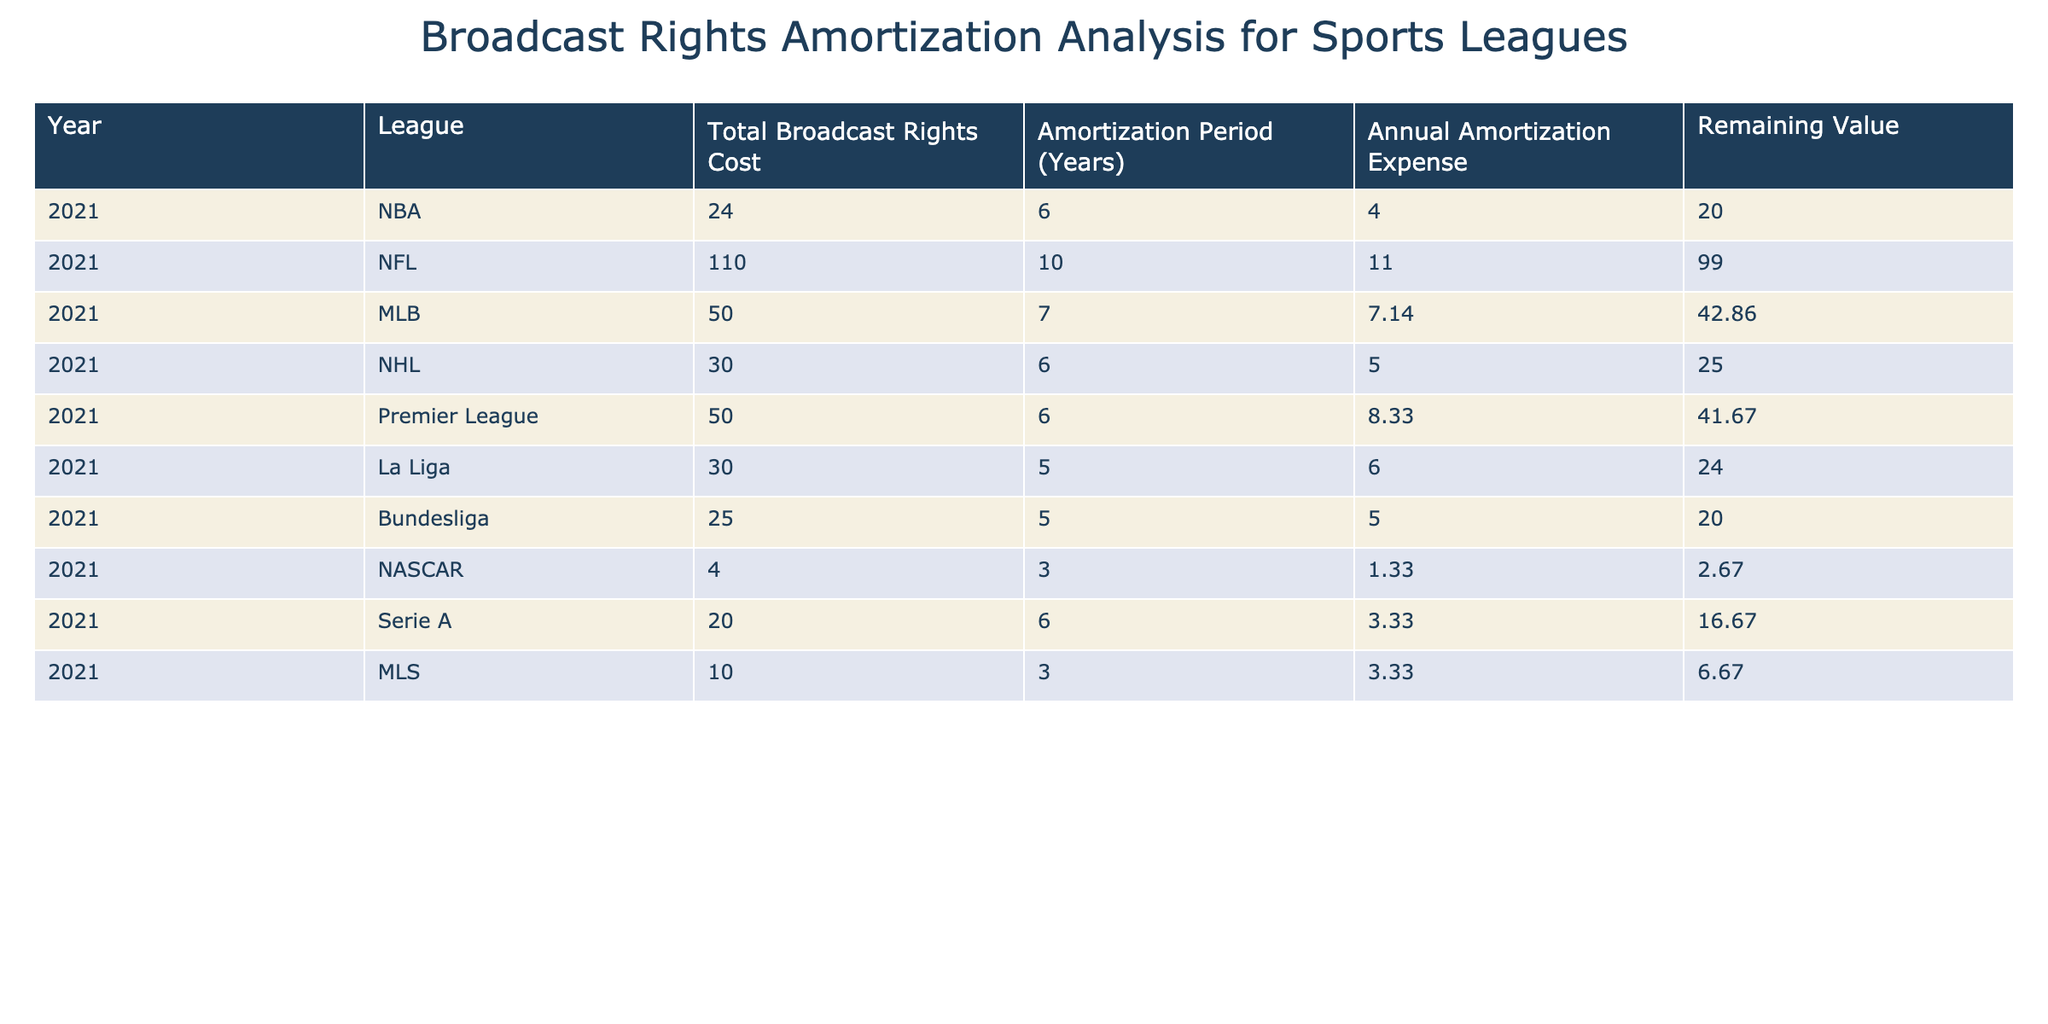What is the total broadcast rights cost for the NFL? Referring to the table, the 'Total Broadcast Rights Cost' for the NFL in the year 2021 is found in the row for the NFL, which states 110.
Answer: 110 Which league has the highest annual amortization expense? By comparing the 'Annual Amortization Expense' column across all leagues, we see that the NFL's value is 11, which is higher than all others.
Answer: NFL What is the remaining value of MLB broadcast rights after one year of amortization? From the table, the 'Remaining Value' for MLB, after one year of amortization, is 42.86 as directly stated in the corresponding row.
Answer: 42.86 Calculate the average annual amortization expense for all leagues combined. First, sum the 'Annual Amortization Expense' values: 4 + 11 + 7.14 + 5 + 8.33 + 6 + 5 + 1.33 + 3.33 + 3.33 = 50.16. Then, divide by the number of leagues (10): 50.16 / 10 = 5.02.
Answer: 5.02 Is the amortization period for Bundesliga shorter than the Premier League? By comparing the 'Amortization Period (Years)' column, Bundesliga has an amortization period of 5 years whereas the Premier League has 6 years indicating that Bundesliga's period is shorter.
Answer: Yes What is the total remaining value of all leagues broadcast rights combined? To find this, sum all values in the 'Remaining Value' column: 20 + 99 + 42.86 + 25 + 41.67 + 24 + 20 + 2.67 + 16.67 + 6.67 = 299.84.
Answer: 299.84 Does La Liga have a higher annual amortization expense than the NHL? Comparing the 'Annual Amortization Expense' values, La Liga shows 6 while NHL shows 5, indicating that La Liga has a higher expense than NHL.
Answer: Yes What is the difference in total broadcast rights cost between the NBA and Serie A? The NBA's total cost is 24 and Serie A's is 20. Calculating the difference gives us 24 - 20 = 4.
Answer: 4 Which league would take the longest to amortize based on the amortization period? By examining the 'Amortization Period (Years)' column, the NFL with 10 years has the longest amortization period in the table, indicating it would take the longest to amortize.
Answer: NFL 